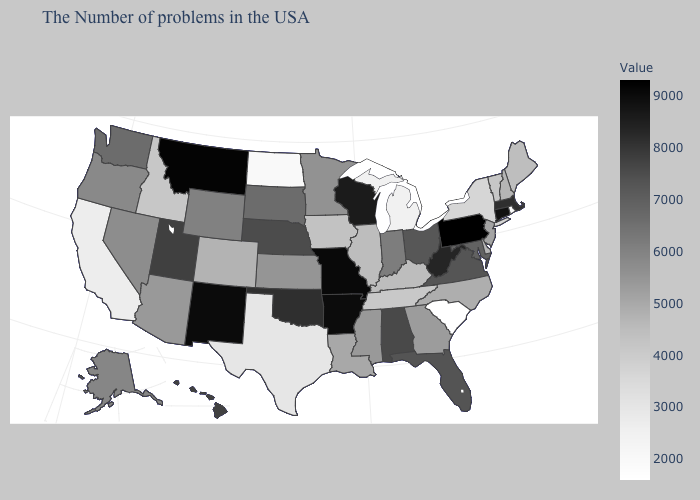Among the states that border Washington , which have the lowest value?
Be succinct. Idaho. Does Colorado have the highest value in the West?
Keep it brief. No. Does Hawaii have a higher value than South Dakota?
Give a very brief answer. Yes. Does Oregon have a higher value than New York?
Be succinct. Yes. Which states have the lowest value in the USA?
Concise answer only. South Carolina. Among the states that border Michigan , does Indiana have the lowest value?
Give a very brief answer. Yes. 